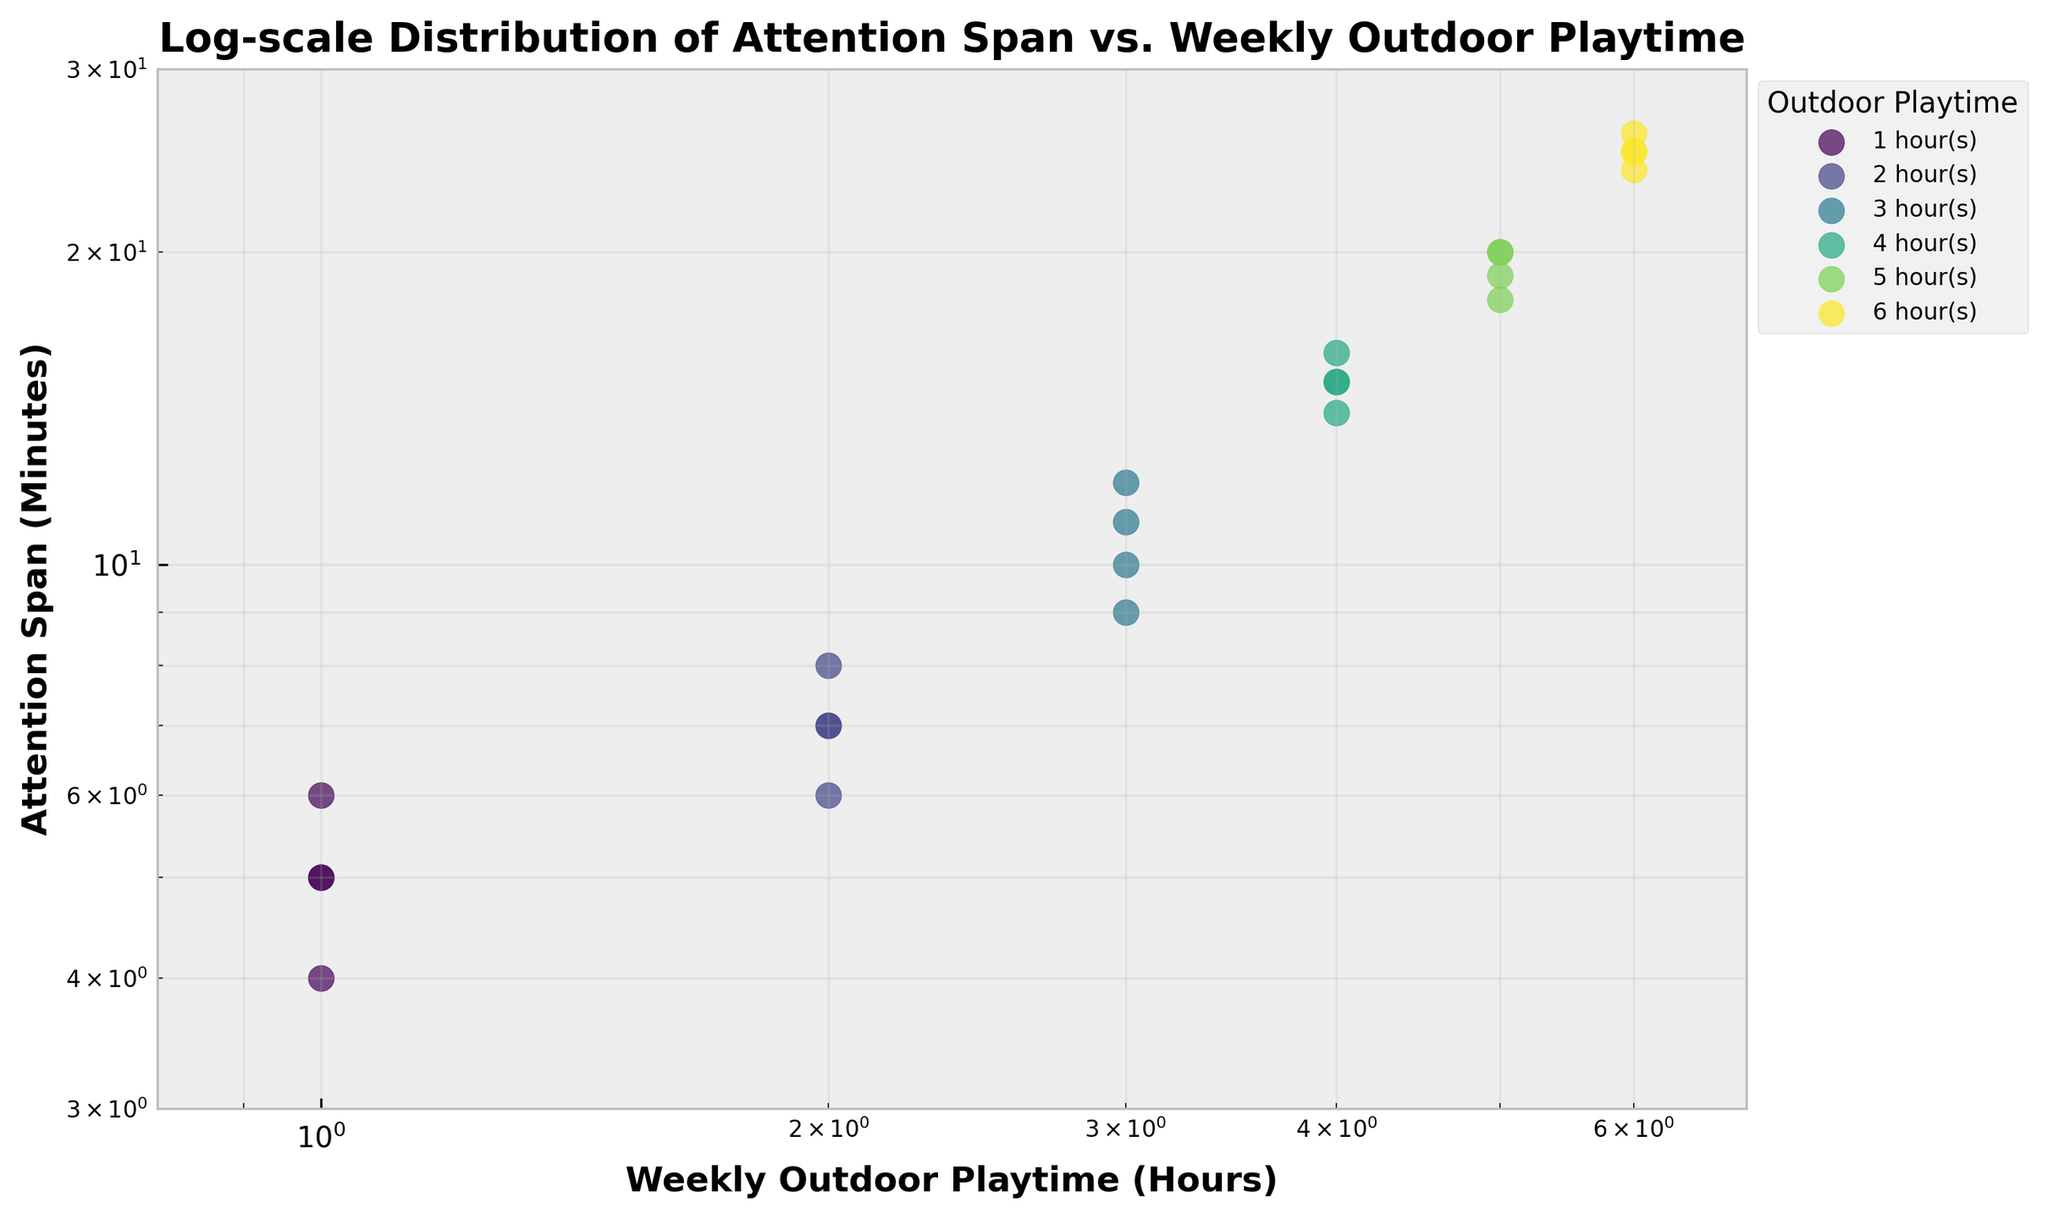What's the title of the figure? The title is given at the top of the plot and should be read directly off the figure.
Answer: Log-scale Distribution of Attention Span vs. Weekly Outdoor Playtime What are the labels for the x-axis and y-axis? The x-axis and y-axis labels describe what each axis represents and can be found beneath the x-axis and left of the y-axis, respectively.
Answer: Weekly Outdoor Playtime (Hours) and Attention Span (Minutes) How many different categories of weekly outdoor playtime are there? Count the unique categories listed in the legend to the right of the plot.
Answer: 6 Which category of outdoor playtime has the largest spread in attention spans? Compare the vertical spread (range) of points for each category along the y-axis to determine which has the widest range.
Answer: 3 hours How does the trend of attention span change with increasing weekly outdoor playtime? Observe the overall direction of the data points as you move from left to right along the x-axis. Note whether the y-values generally increase or decrease.
Answer: Generally increases Is the relationship between weekly outdoor playtime and attention span linear or non-linear? Since the plot uses log scales on both axes, check if the points form a straight line or a curve to infer the relationship.
Answer: Non-linear Which category of outdoor playtime shows points representing attention spans between 24 and 26 minutes? Identify the group from which points fall within the given y-axis range by looking at the legend and colored points.
Answer: 6 hours What is the range of attention spans for children who play outdoors for 2 hours weekly? Determine the minimum and maximum y-values of points in the '2 hour(s)' category.
Answer: 6 to 8 minutes How does the variability of attention spans compare between children who play 1 hour and those who play 5 hours outdoors weekly? Compare the spreads (range) of dots for the 1-hour and 5-hour categories along the y-axis. The 1-hour spread is from 4 to 6 minutes, and the 5-hour spread is from 18 to 20 minutes.
Answer: 5 hours have a larger spread 